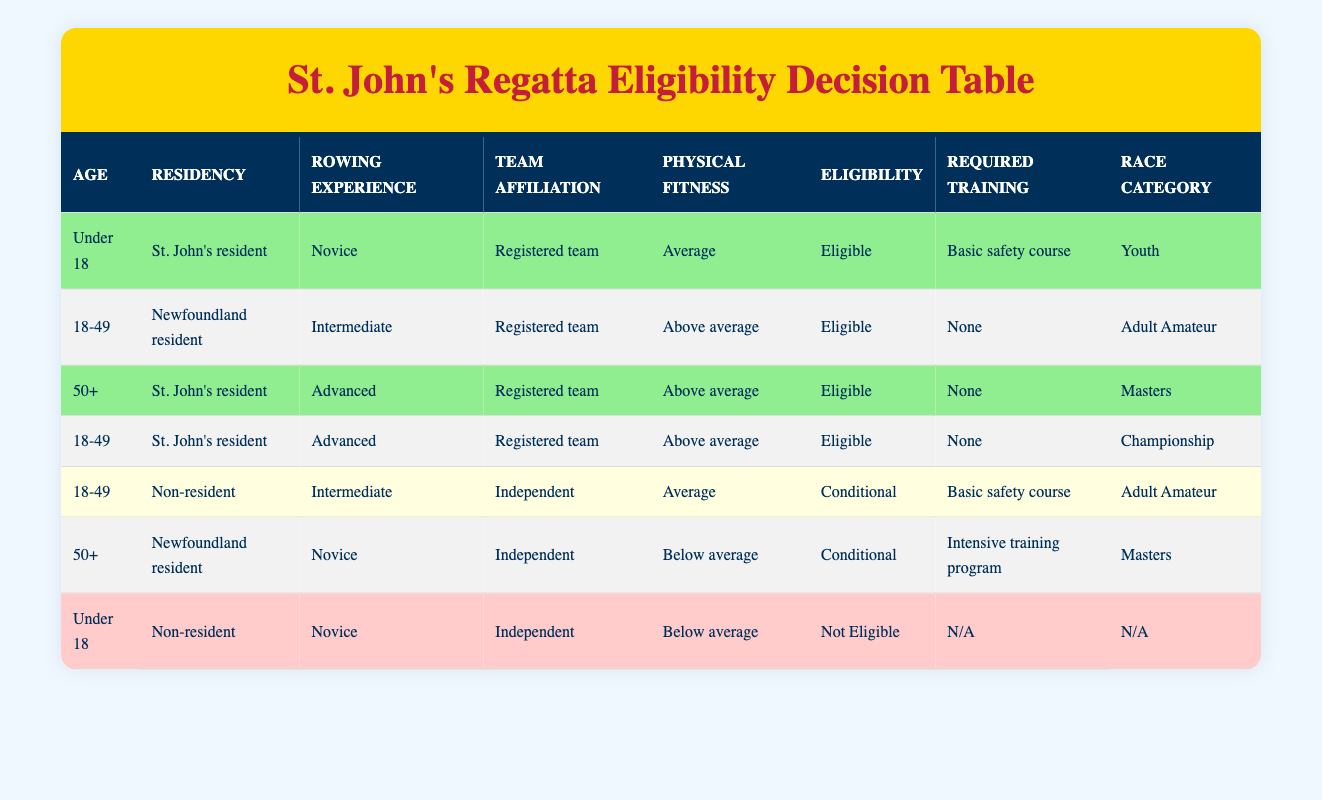What is the eligibility status for a 50+ St. John's resident with advanced rowing experience? In the table, the row that fits this description shows the eligibility status is "Eligible." It meets all the criteria, having a registered team affiliation and above average physical fitness.
Answer: Eligible How many different race categories exist for participants based on the table? The table lists four race categories: Youth, Adult Amateur, Masters, and Championship. Therefore, there are 4 distinct categories available for participants.
Answer: 4 Is a non-resident under 18 with novice experience eligible to participate? The row corresponding to this description states that the eligibility is "Not Eligible." This indicates that under 18 non-resident participants do not meet the eligibility requirements.
Answer: Not Eligible What training is required for an 18-49-year-old non-resident intermediate rower who is independent? According to the table, this specific scenario indicates a "Conditional" eligibility and requires a "Basic safety course" as training.
Answer: Basic safety course What is the total number of eligible participants based on the table? The eligible status applies to four entries: under 18 St. John's resident novice, 18-49 Newfoundland resident intermediate, 50+ St. John's resident advanced, and 18-49 St. John's resident advanced. By counting these four rows, the total comes to 4 eligible participants.
Answer: 4 Are there any participants who are both eligible and require an intensive training program? By examining the table, all eligible participants have either "None" or "Basic safety course" as their required training. There are no entries indicating eligible participants requiring an intensive training program.
Answer: No What is the required training for a 50+ Newfoundland resident with novice experience who is independent? Looking at the table, this case is classified as "Conditional," and requires an "Intensive training program," specifically indicating additional training before eligibility.
Answer: Intensive training program What age group has the highest number of eligible participants? The table reveals there are 4 eligible participants: one in each age category except for the 50+ age group with novice experience. Thus, both the Under 18 and 18-49 categories have 2 eligible participants in total, but 18-49 age group has more variations, hence the highest number.
Answer: 18-49 age group What is the eligibility status of an under 18 St. John's resident novice rower? The eligibility status for this participant can be found in the table, where it's stated as "Eligible." The criteria—being a St. John's resident, novice with average physical fitness—are met.
Answer: Eligible 